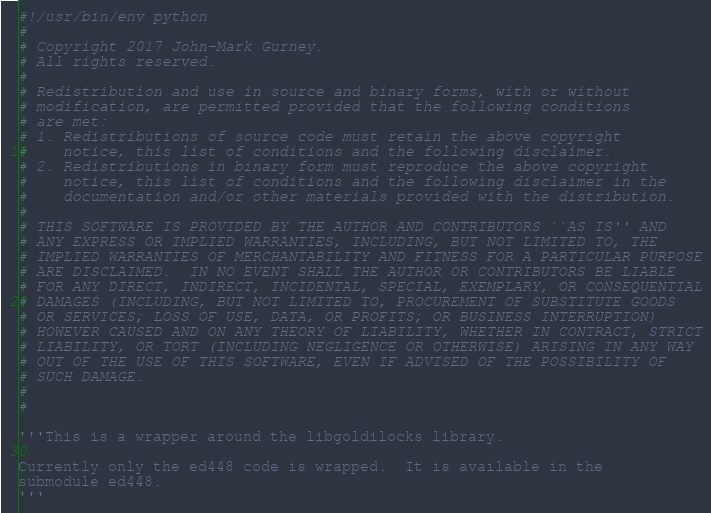<code> <loc_0><loc_0><loc_500><loc_500><_Python_>#!/usr/bin/env python
#
# Copyright 2017 John-Mark Gurney.
# All rights reserved.
#
# Redistribution and use in source and binary forms, with or without
# modification, are permitted provided that the following conditions
# are met:
# 1. Redistributions of source code must retain the above copyright
#    notice, this list of conditions and the following disclaimer.
# 2. Redistributions in binary form must reproduce the above copyright
#    notice, this list of conditions and the following disclaimer in the
#    documentation and/or other materials provided with the distribution.
#
# THIS SOFTWARE IS PROVIDED BY THE AUTHOR AND CONTRIBUTORS ``AS IS'' AND
# ANY EXPRESS OR IMPLIED WARRANTIES, INCLUDING, BUT NOT LIMITED TO, THE
# IMPLIED WARRANTIES OF MERCHANTABILITY AND FITNESS FOR A PARTICULAR PURPOSE
# ARE DISCLAIMED.  IN NO EVENT SHALL THE AUTHOR OR CONTRIBUTORS BE LIABLE
# FOR ANY DIRECT, INDIRECT, INCIDENTAL, SPECIAL, EXEMPLARY, OR CONSEQUENTIAL
# DAMAGES (INCLUDING, BUT NOT LIMITED TO, PROCUREMENT OF SUBSTITUTE GOODS
# OR SERVICES; LOSS OF USE, DATA, OR PROFITS; OR BUSINESS INTERRUPTION)
# HOWEVER CAUSED AND ON ANY THEORY OF LIABILITY, WHETHER IN CONTRACT, STRICT
# LIABILITY, OR TORT (INCLUDING NEGLIGENCE OR OTHERWISE) ARISING IN ANY WAY
# OUT OF THE USE OF THIS SOFTWARE, EVEN IF ADVISED OF THE POSSIBILITY OF
# SUCH DAMAGE.
#
#

'''This is a wrapper around the libgoldilocks library.

Currently only the ed448 code is wrapped.  It is available in the
submodule ed448.
'''
</code> 